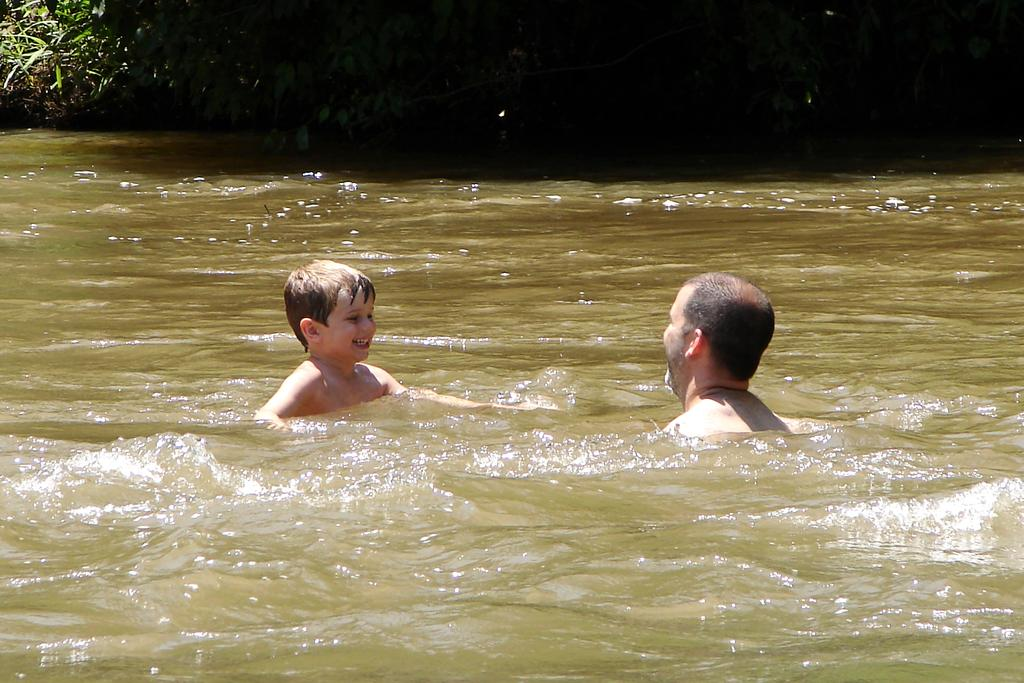How many people are in the water in the image? There are two persons in the water in the image. What type of plants can be seen at the top of the image? Plants are visible at the top of the image. Where is the basket located in the image? There is no basket present in the image. What type of flower can be seen growing near the water in the image? There is no flower present in the image. Can you see a match being lit in the image? There is no match being lit in the image. 